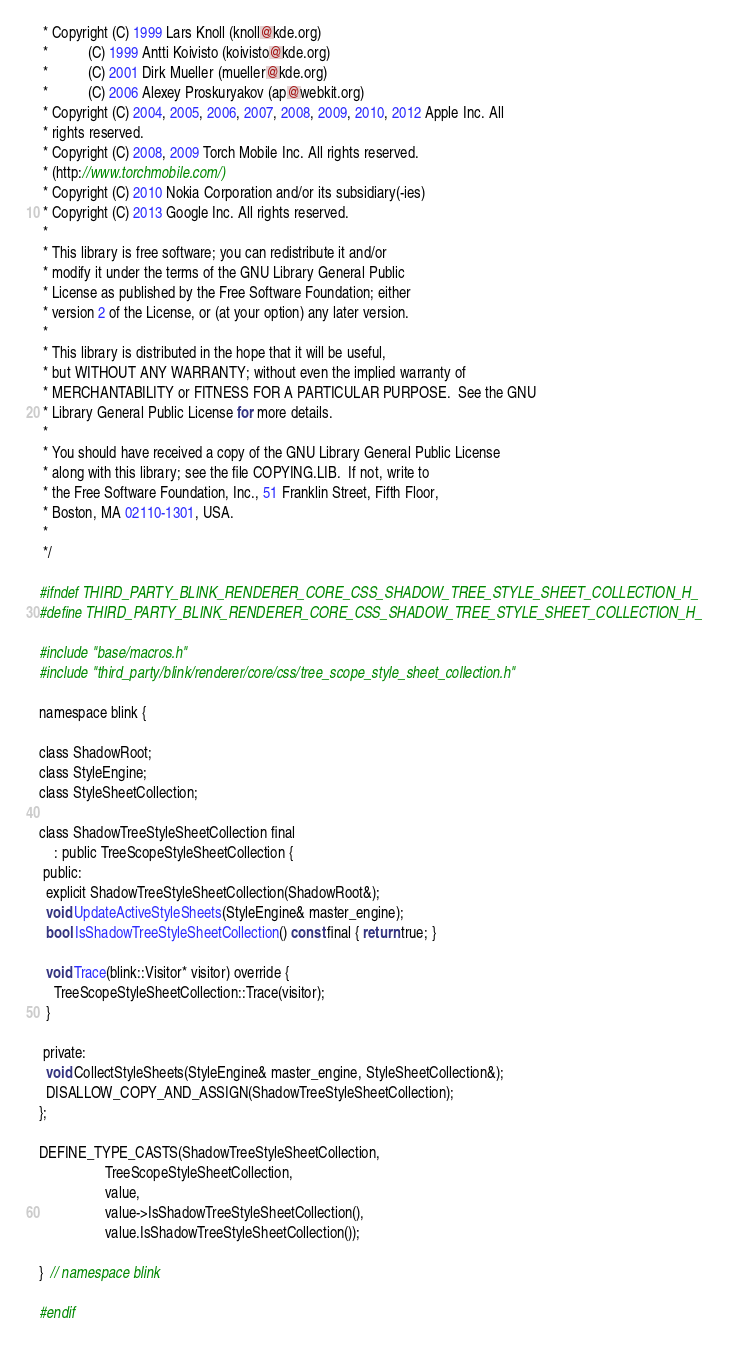<code> <loc_0><loc_0><loc_500><loc_500><_C_> * Copyright (C) 1999 Lars Knoll (knoll@kde.org)
 *           (C) 1999 Antti Koivisto (koivisto@kde.org)
 *           (C) 2001 Dirk Mueller (mueller@kde.org)
 *           (C) 2006 Alexey Proskuryakov (ap@webkit.org)
 * Copyright (C) 2004, 2005, 2006, 2007, 2008, 2009, 2010, 2012 Apple Inc. All
 * rights reserved.
 * Copyright (C) 2008, 2009 Torch Mobile Inc. All rights reserved.
 * (http://www.torchmobile.com/)
 * Copyright (C) 2010 Nokia Corporation and/or its subsidiary(-ies)
 * Copyright (C) 2013 Google Inc. All rights reserved.
 *
 * This library is free software; you can redistribute it and/or
 * modify it under the terms of the GNU Library General Public
 * License as published by the Free Software Foundation; either
 * version 2 of the License, or (at your option) any later version.
 *
 * This library is distributed in the hope that it will be useful,
 * but WITHOUT ANY WARRANTY; without even the implied warranty of
 * MERCHANTABILITY or FITNESS FOR A PARTICULAR PURPOSE.  See the GNU
 * Library General Public License for more details.
 *
 * You should have received a copy of the GNU Library General Public License
 * along with this library; see the file COPYING.LIB.  If not, write to
 * the Free Software Foundation, Inc., 51 Franklin Street, Fifth Floor,
 * Boston, MA 02110-1301, USA.
 *
 */

#ifndef THIRD_PARTY_BLINK_RENDERER_CORE_CSS_SHADOW_TREE_STYLE_SHEET_COLLECTION_H_
#define THIRD_PARTY_BLINK_RENDERER_CORE_CSS_SHADOW_TREE_STYLE_SHEET_COLLECTION_H_

#include "base/macros.h"
#include "third_party/blink/renderer/core/css/tree_scope_style_sheet_collection.h"

namespace blink {

class ShadowRoot;
class StyleEngine;
class StyleSheetCollection;

class ShadowTreeStyleSheetCollection final
    : public TreeScopeStyleSheetCollection {
 public:
  explicit ShadowTreeStyleSheetCollection(ShadowRoot&);
  void UpdateActiveStyleSheets(StyleEngine& master_engine);
  bool IsShadowTreeStyleSheetCollection() const final { return true; }

  void Trace(blink::Visitor* visitor) override {
    TreeScopeStyleSheetCollection::Trace(visitor);
  }

 private:
  void CollectStyleSheets(StyleEngine& master_engine, StyleSheetCollection&);
  DISALLOW_COPY_AND_ASSIGN(ShadowTreeStyleSheetCollection);
};

DEFINE_TYPE_CASTS(ShadowTreeStyleSheetCollection,
                  TreeScopeStyleSheetCollection,
                  value,
                  value->IsShadowTreeStyleSheetCollection(),
                  value.IsShadowTreeStyleSheetCollection());

}  // namespace blink

#endif
</code> 